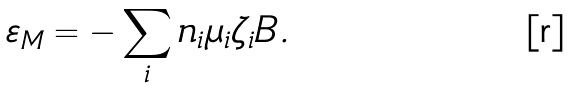<formula> <loc_0><loc_0><loc_500><loc_500>\varepsilon _ { M } = - \sum _ { i } n _ { i } \mu _ { i } \zeta _ { i } B .</formula> 